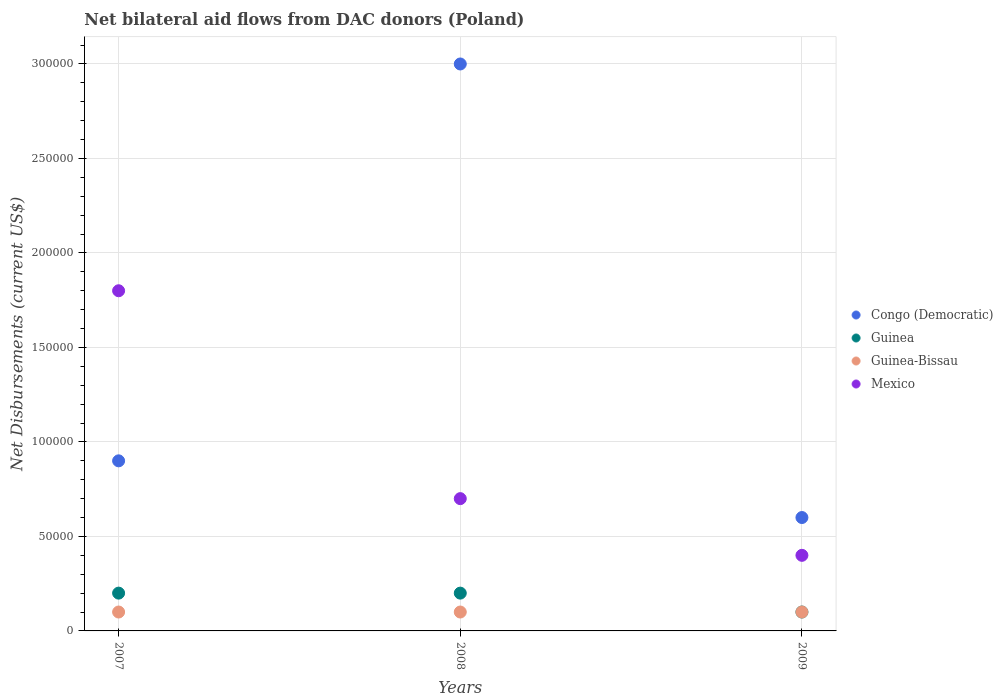Across all years, what is the maximum net bilateral aid flows in Guinea-Bissau?
Give a very brief answer. 10000. Across all years, what is the minimum net bilateral aid flows in Congo (Democratic)?
Offer a very short reply. 6.00e+04. In which year was the net bilateral aid flows in Congo (Democratic) maximum?
Your response must be concise. 2008. In which year was the net bilateral aid flows in Guinea minimum?
Ensure brevity in your answer.  2009. What is the total net bilateral aid flows in Congo (Democratic) in the graph?
Your answer should be very brief. 4.50e+05. What is the difference between the net bilateral aid flows in Mexico in 2009 and the net bilateral aid flows in Congo (Democratic) in 2007?
Offer a terse response. -5.00e+04. In the year 2008, what is the difference between the net bilateral aid flows in Guinea-Bissau and net bilateral aid flows in Congo (Democratic)?
Provide a succinct answer. -2.90e+05. What is the difference between the highest and the second highest net bilateral aid flows in Congo (Democratic)?
Ensure brevity in your answer.  2.10e+05. What is the difference between the highest and the lowest net bilateral aid flows in Mexico?
Your answer should be very brief. 1.40e+05. In how many years, is the net bilateral aid flows in Mexico greater than the average net bilateral aid flows in Mexico taken over all years?
Your answer should be very brief. 1. Is it the case that in every year, the sum of the net bilateral aid flows in Congo (Democratic) and net bilateral aid flows in Guinea  is greater than the sum of net bilateral aid flows in Mexico and net bilateral aid flows in Guinea-Bissau?
Your answer should be very brief. No. Does the net bilateral aid flows in Congo (Democratic) monotonically increase over the years?
Offer a terse response. No. How many dotlines are there?
Your response must be concise. 4. Are the values on the major ticks of Y-axis written in scientific E-notation?
Provide a short and direct response. No. Does the graph contain any zero values?
Ensure brevity in your answer.  No. Where does the legend appear in the graph?
Your answer should be compact. Center right. How many legend labels are there?
Keep it short and to the point. 4. How are the legend labels stacked?
Offer a terse response. Vertical. What is the title of the graph?
Offer a terse response. Net bilateral aid flows from DAC donors (Poland). What is the label or title of the X-axis?
Offer a terse response. Years. What is the label or title of the Y-axis?
Your answer should be very brief. Net Disbursements (current US$). What is the Net Disbursements (current US$) of Mexico in 2007?
Provide a short and direct response. 1.80e+05. What is the Net Disbursements (current US$) of Congo (Democratic) in 2009?
Offer a very short reply. 6.00e+04. What is the Net Disbursements (current US$) of Guinea in 2009?
Your answer should be very brief. 10000. What is the Net Disbursements (current US$) in Mexico in 2009?
Your response must be concise. 4.00e+04. Across all years, what is the maximum Net Disbursements (current US$) of Guinea?
Provide a short and direct response. 2.00e+04. Across all years, what is the maximum Net Disbursements (current US$) of Mexico?
Ensure brevity in your answer.  1.80e+05. Across all years, what is the minimum Net Disbursements (current US$) in Congo (Democratic)?
Make the answer very short. 6.00e+04. Across all years, what is the minimum Net Disbursements (current US$) of Guinea?
Provide a succinct answer. 10000. Across all years, what is the minimum Net Disbursements (current US$) of Guinea-Bissau?
Your response must be concise. 10000. Across all years, what is the minimum Net Disbursements (current US$) of Mexico?
Offer a terse response. 4.00e+04. What is the total Net Disbursements (current US$) in Congo (Democratic) in the graph?
Your answer should be compact. 4.50e+05. What is the total Net Disbursements (current US$) of Guinea-Bissau in the graph?
Ensure brevity in your answer.  3.00e+04. What is the difference between the Net Disbursements (current US$) of Congo (Democratic) in 2007 and that in 2008?
Your answer should be compact. -2.10e+05. What is the difference between the Net Disbursements (current US$) of Guinea in 2007 and that in 2008?
Offer a very short reply. 0. What is the difference between the Net Disbursements (current US$) in Guinea-Bissau in 2007 and that in 2008?
Ensure brevity in your answer.  0. What is the difference between the Net Disbursements (current US$) of Mexico in 2007 and that in 2008?
Offer a very short reply. 1.10e+05. What is the difference between the Net Disbursements (current US$) of Guinea in 2007 and that in 2009?
Provide a short and direct response. 10000. What is the difference between the Net Disbursements (current US$) of Guinea-Bissau in 2008 and that in 2009?
Provide a short and direct response. 0. What is the difference between the Net Disbursements (current US$) in Mexico in 2008 and that in 2009?
Your answer should be compact. 3.00e+04. What is the difference between the Net Disbursements (current US$) in Congo (Democratic) in 2007 and the Net Disbursements (current US$) in Guinea in 2008?
Give a very brief answer. 7.00e+04. What is the difference between the Net Disbursements (current US$) of Congo (Democratic) in 2007 and the Net Disbursements (current US$) of Mexico in 2008?
Your answer should be very brief. 2.00e+04. What is the difference between the Net Disbursements (current US$) in Guinea in 2007 and the Net Disbursements (current US$) in Guinea-Bissau in 2008?
Your answer should be very brief. 10000. What is the difference between the Net Disbursements (current US$) of Guinea-Bissau in 2007 and the Net Disbursements (current US$) of Mexico in 2008?
Make the answer very short. -6.00e+04. What is the difference between the Net Disbursements (current US$) of Guinea-Bissau in 2007 and the Net Disbursements (current US$) of Mexico in 2009?
Offer a terse response. -3.00e+04. What is the difference between the Net Disbursements (current US$) of Guinea in 2008 and the Net Disbursements (current US$) of Guinea-Bissau in 2009?
Your answer should be compact. 10000. What is the difference between the Net Disbursements (current US$) in Guinea-Bissau in 2008 and the Net Disbursements (current US$) in Mexico in 2009?
Provide a short and direct response. -3.00e+04. What is the average Net Disbursements (current US$) in Guinea per year?
Make the answer very short. 1.67e+04. What is the average Net Disbursements (current US$) of Guinea-Bissau per year?
Provide a short and direct response. 10000. What is the average Net Disbursements (current US$) of Mexico per year?
Offer a very short reply. 9.67e+04. In the year 2007, what is the difference between the Net Disbursements (current US$) of Guinea and Net Disbursements (current US$) of Guinea-Bissau?
Your response must be concise. 10000. In the year 2008, what is the difference between the Net Disbursements (current US$) of Congo (Democratic) and Net Disbursements (current US$) of Guinea-Bissau?
Provide a short and direct response. 2.90e+05. In the year 2008, what is the difference between the Net Disbursements (current US$) in Guinea-Bissau and Net Disbursements (current US$) in Mexico?
Keep it short and to the point. -6.00e+04. In the year 2009, what is the difference between the Net Disbursements (current US$) in Congo (Democratic) and Net Disbursements (current US$) in Guinea-Bissau?
Provide a succinct answer. 5.00e+04. What is the ratio of the Net Disbursements (current US$) of Congo (Democratic) in 2007 to that in 2008?
Your response must be concise. 0.3. What is the ratio of the Net Disbursements (current US$) in Mexico in 2007 to that in 2008?
Your response must be concise. 2.57. What is the ratio of the Net Disbursements (current US$) in Congo (Democratic) in 2007 to that in 2009?
Provide a succinct answer. 1.5. What is the ratio of the Net Disbursements (current US$) in Guinea in 2007 to that in 2009?
Your response must be concise. 2. What is the difference between the highest and the second highest Net Disbursements (current US$) of Congo (Democratic)?
Make the answer very short. 2.10e+05. What is the difference between the highest and the second highest Net Disbursements (current US$) of Guinea-Bissau?
Keep it short and to the point. 0. What is the difference between the highest and the lowest Net Disbursements (current US$) of Congo (Democratic)?
Offer a very short reply. 2.40e+05. What is the difference between the highest and the lowest Net Disbursements (current US$) of Mexico?
Offer a very short reply. 1.40e+05. 